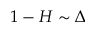Convert formula to latex. <formula><loc_0><loc_0><loc_500><loc_500>1 - H \sim \Delta</formula> 